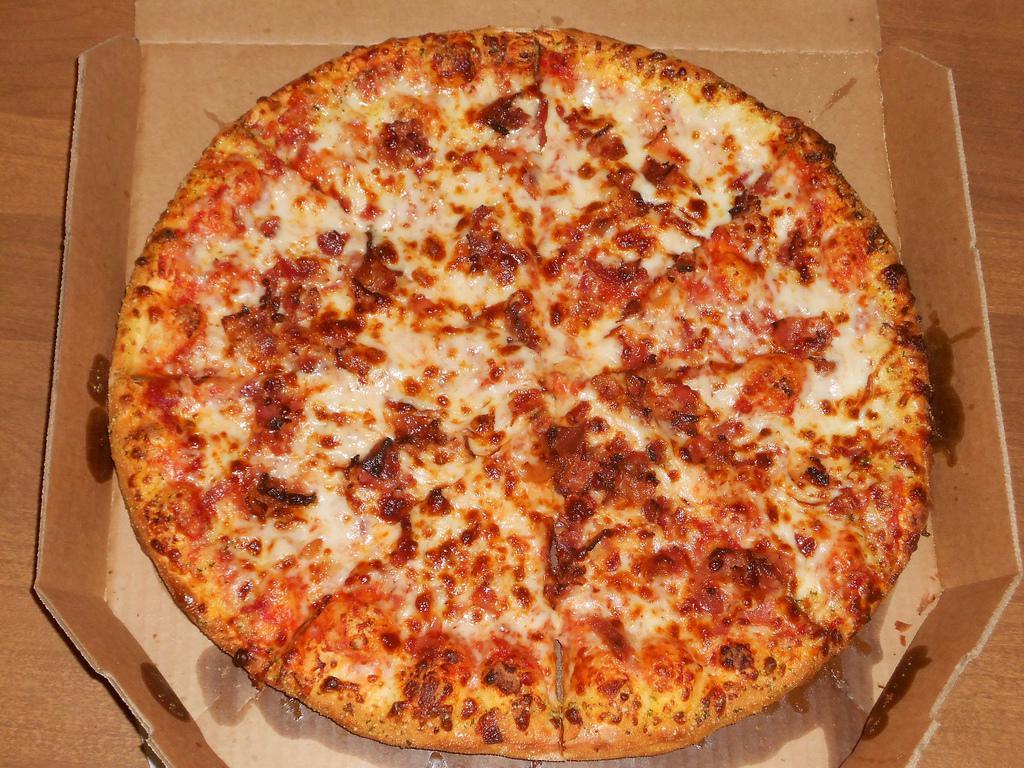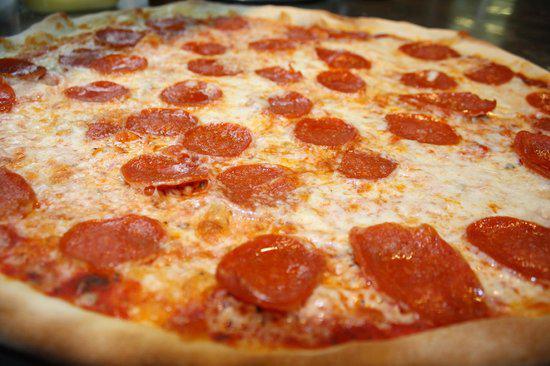The first image is the image on the left, the second image is the image on the right. Given the left and right images, does the statement "There are two pizzas with one still in a cardboard box." hold true? Answer yes or no. Yes. The first image is the image on the left, the second image is the image on the right. Considering the images on both sides, is "The pizza in the image on the left is sitting in a cardboard box." valid? Answer yes or no. Yes. 